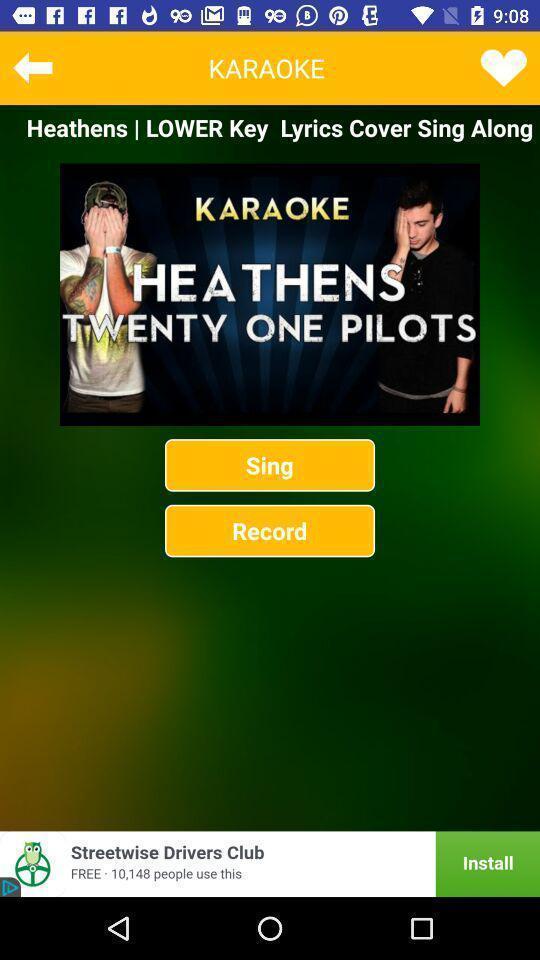Tell me what you see in this picture. Song to record in music app. 